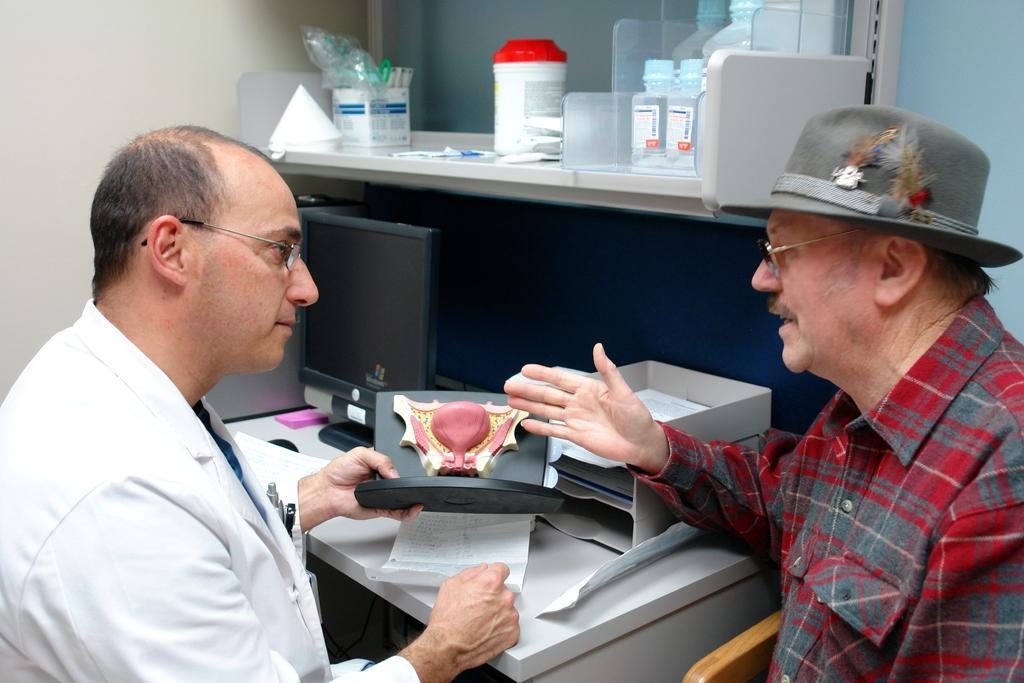Can you describe this image briefly? In this image, we can see persons wearing clothes. There is a person on the left side of the image holding an object with his hand. There is a table at the bottom of the image contains boxes and monitor. There is a wall shelf at the top of the image contains some bottles. 